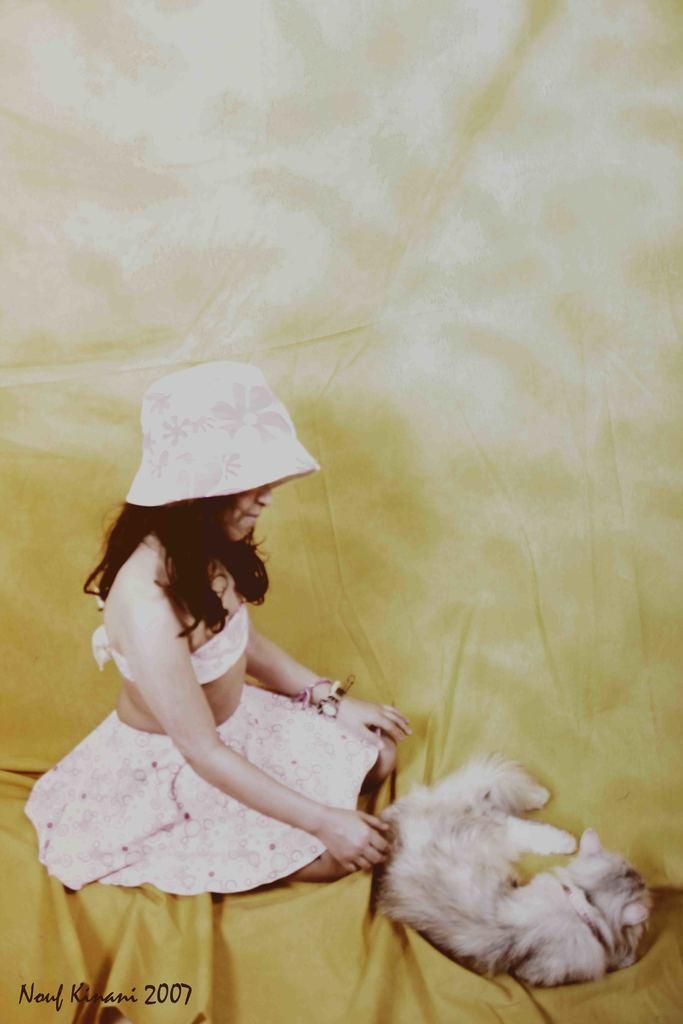Who is the main subject in the foreground of the image? There is a girl in the foreground of the image. What is the girl wearing on her head? The girl is wearing a hat. What is the girl sitting on in the image? The girl is sitting on a yellow color cloth. What can be seen in front of the girl? There is an animal in front of the girl. What type of picture is the girl holding in the image? There is no picture visible in the image; the girl is not holding anything. 